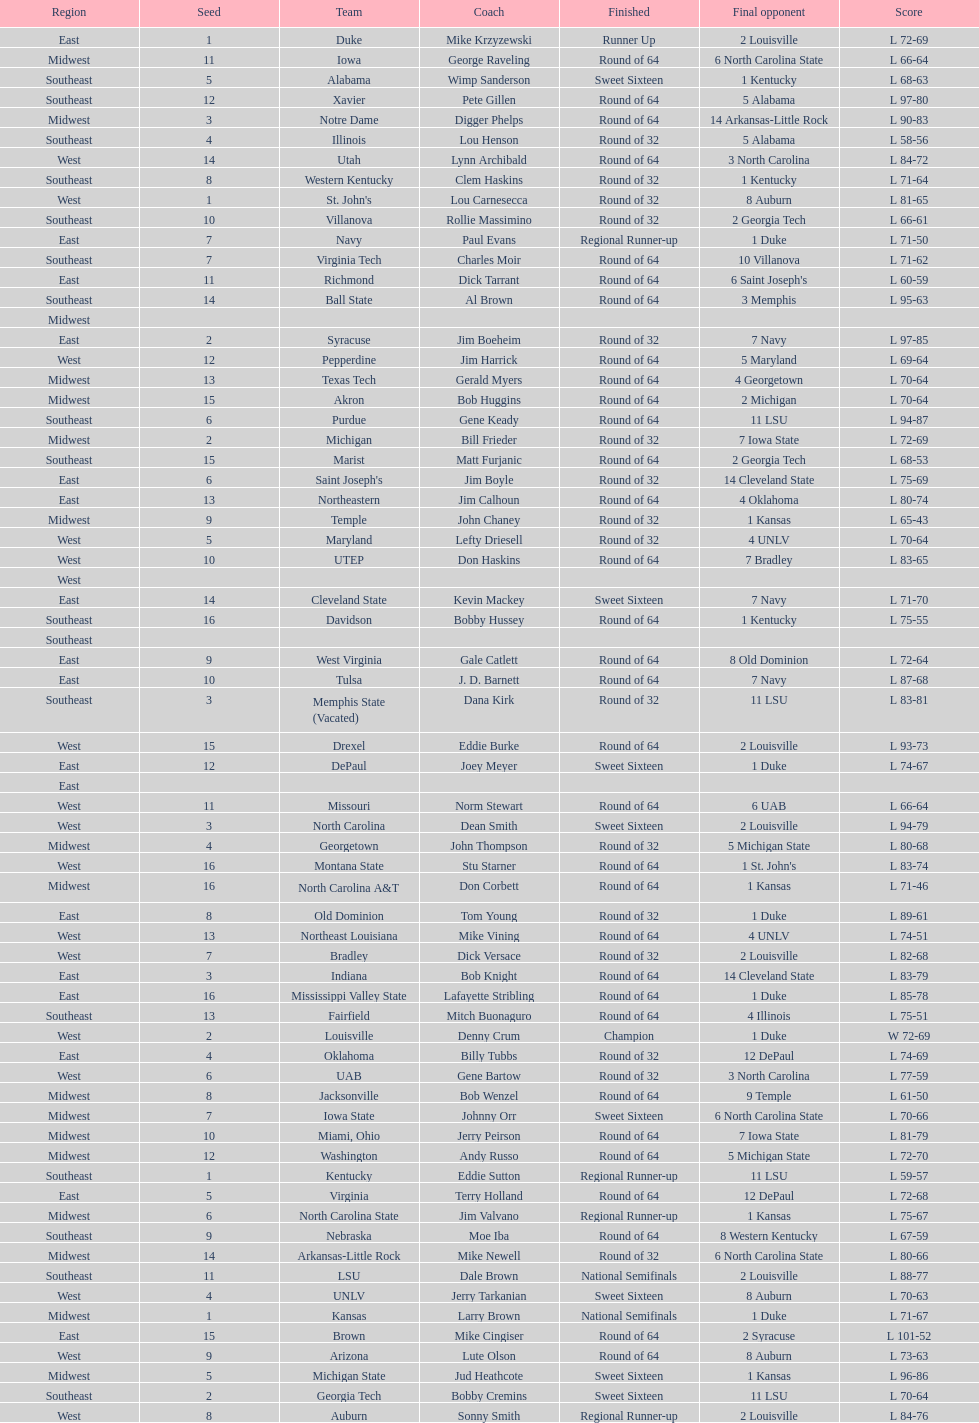What team finished at the top of all else and was finished as champions? Louisville. 